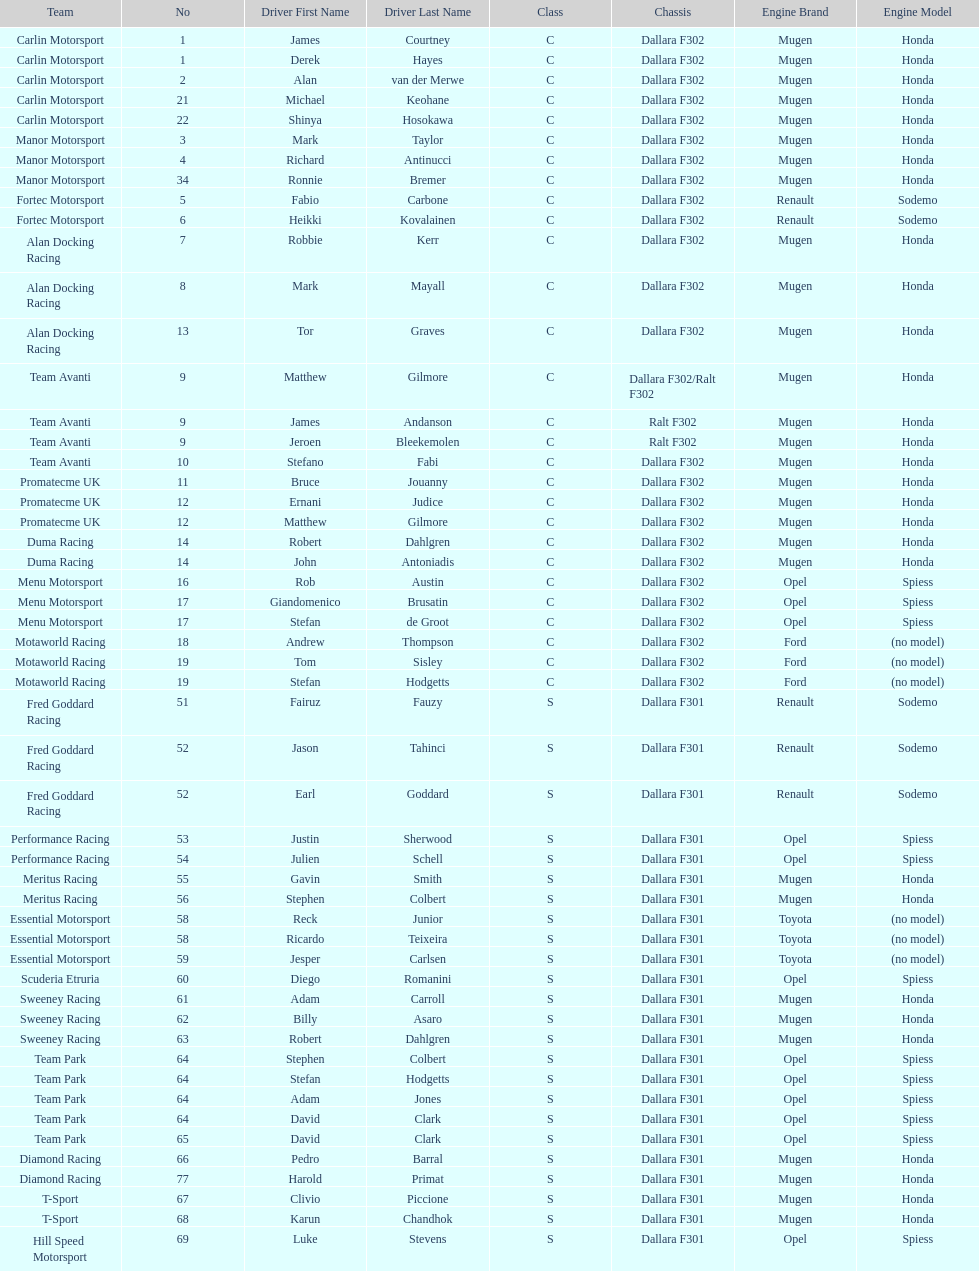What is the total number of class c (championship) teams? 21. 